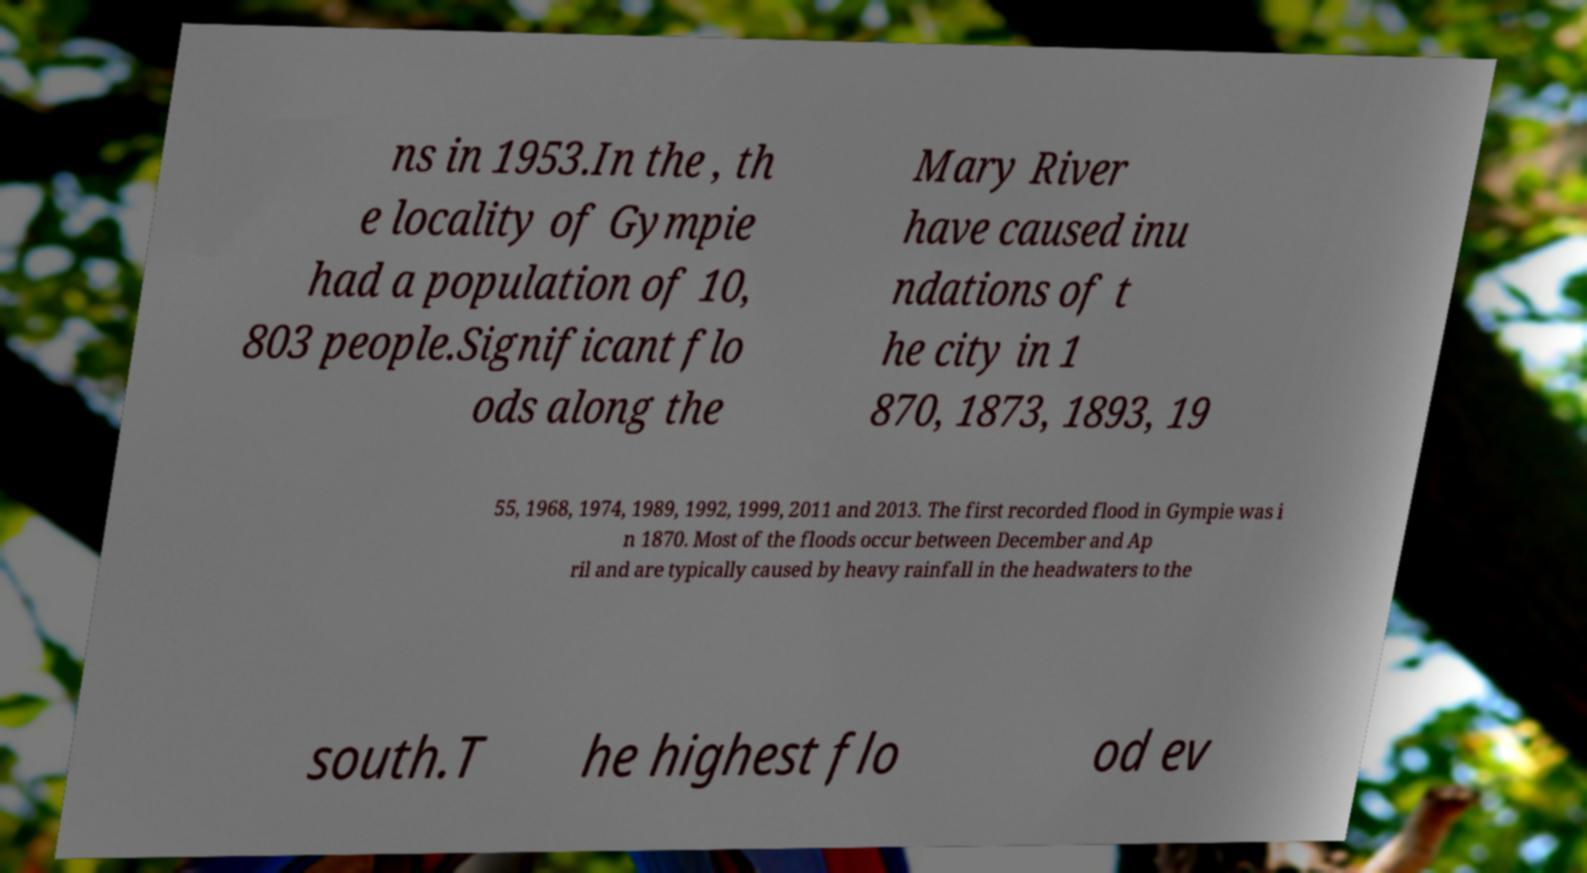Can you read and provide the text displayed in the image?This photo seems to have some interesting text. Can you extract and type it out for me? ns in 1953.In the , th e locality of Gympie had a population of 10, 803 people.Significant flo ods along the Mary River have caused inu ndations of t he city in 1 870, 1873, 1893, 19 55, 1968, 1974, 1989, 1992, 1999, 2011 and 2013. The first recorded flood in Gympie was i n 1870. Most of the floods occur between December and Ap ril and are typically caused by heavy rainfall in the headwaters to the south.T he highest flo od ev 